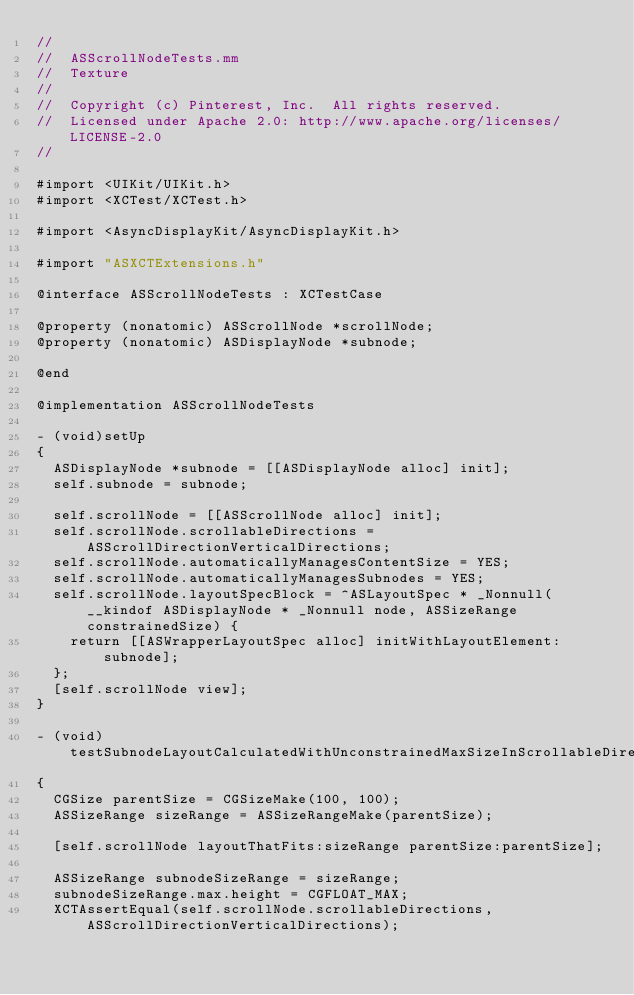Convert code to text. <code><loc_0><loc_0><loc_500><loc_500><_ObjectiveC_>//
//  ASScrollNodeTests.mm
//  Texture
//
//  Copyright (c) Pinterest, Inc.  All rights reserved.
//  Licensed under Apache 2.0: http://www.apache.org/licenses/LICENSE-2.0
//

#import <UIKit/UIKit.h>
#import <XCTest/XCTest.h>

#import <AsyncDisplayKit/AsyncDisplayKit.h>

#import "ASXCTExtensions.h"

@interface ASScrollNodeTests : XCTestCase

@property (nonatomic) ASScrollNode *scrollNode;
@property (nonatomic) ASDisplayNode *subnode;

@end

@implementation ASScrollNodeTests

- (void)setUp
{
  ASDisplayNode *subnode = [[ASDisplayNode alloc] init];
  self.subnode = subnode;

  self.scrollNode = [[ASScrollNode alloc] init];
  self.scrollNode.scrollableDirections = ASScrollDirectionVerticalDirections;
  self.scrollNode.automaticallyManagesContentSize = YES;
  self.scrollNode.automaticallyManagesSubnodes = YES;
  self.scrollNode.layoutSpecBlock = ^ASLayoutSpec * _Nonnull(__kindof ASDisplayNode * _Nonnull node, ASSizeRange constrainedSize) {
    return [[ASWrapperLayoutSpec alloc] initWithLayoutElement:subnode];
  };
  [self.scrollNode view];
}

- (void)testSubnodeLayoutCalculatedWithUnconstrainedMaxSizeInScrollableDirection
{
  CGSize parentSize = CGSizeMake(100, 100);
  ASSizeRange sizeRange = ASSizeRangeMake(parentSize);

  [self.scrollNode layoutThatFits:sizeRange parentSize:parentSize];

  ASSizeRange subnodeSizeRange = sizeRange;
  subnodeSizeRange.max.height = CGFLOAT_MAX;
  XCTAssertEqual(self.scrollNode.scrollableDirections, ASScrollDirectionVerticalDirections);</code> 